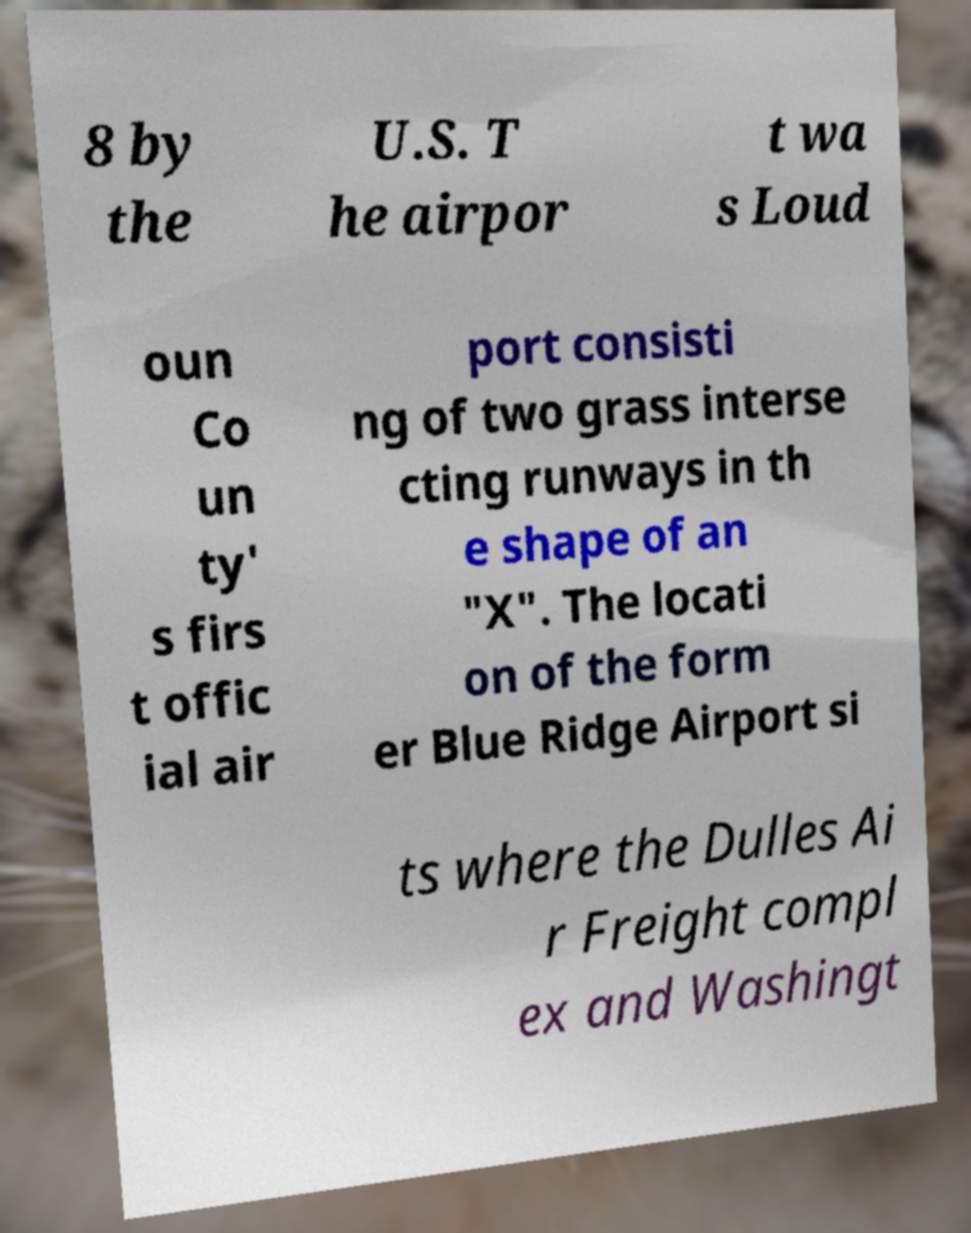Could you assist in decoding the text presented in this image and type it out clearly? 8 by the U.S. T he airpor t wa s Loud oun Co un ty' s firs t offic ial air port consisti ng of two grass interse cting runways in th e shape of an "X". The locati on of the form er Blue Ridge Airport si ts where the Dulles Ai r Freight compl ex and Washingt 